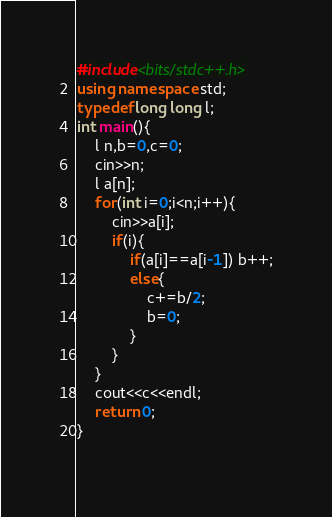Convert code to text. <code><loc_0><loc_0><loc_500><loc_500><_C++_>#include<bits/stdc++.h>
using namespace std;
typedef long long l;
int main(){
    l n,b=0,c=0;
    cin>>n;
    l a[n];
    for(int i=0;i<n;i++){
        cin>>a[i];
        if(i){
            if(a[i]==a[i-1]) b++;
            else{
                c+=b/2;
                b=0;
            }
        }
    }
    cout<<c<<endl;
    return 0;
}
    </code> 